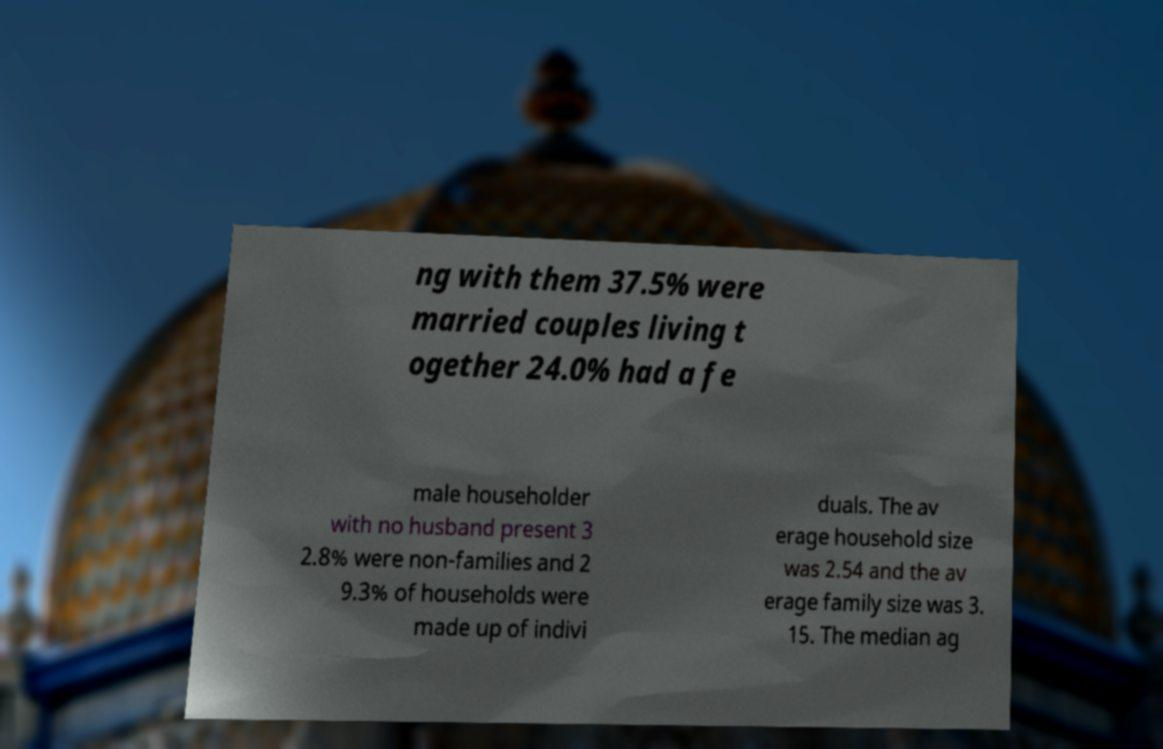Can you accurately transcribe the text from the provided image for me? ng with them 37.5% were married couples living t ogether 24.0% had a fe male householder with no husband present 3 2.8% were non-families and 2 9.3% of households were made up of indivi duals. The av erage household size was 2.54 and the av erage family size was 3. 15. The median ag 